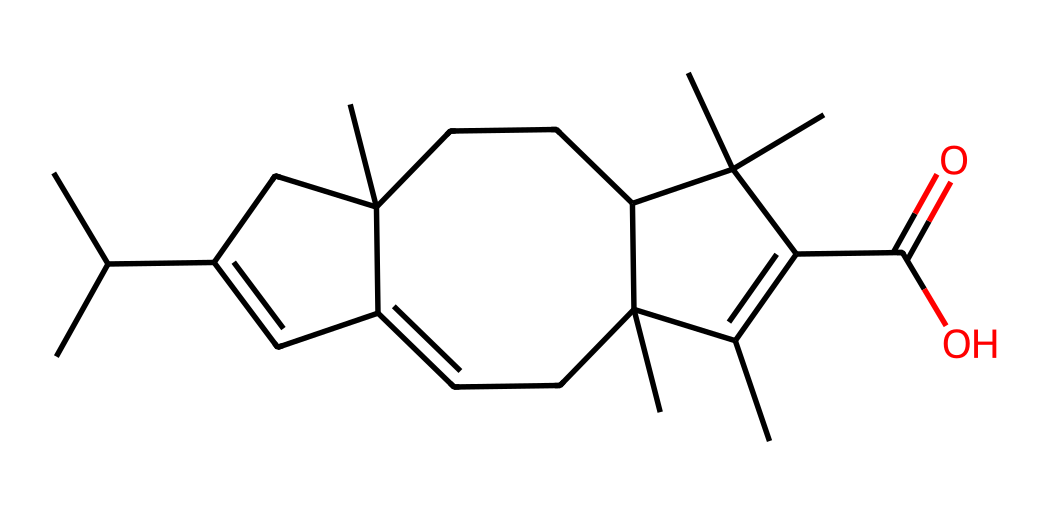What is the functional group present in this chemical structure? The SMILES representation shows a carbonyl group (C=O), which is characteristic of ketones. This functional group is typically located near the center of the molecule, visible in the structure.
Answer: carbonyl How many carbon atoms are in the structure? By analyzing the SMILES representation, we can count a total of 20 carbon atoms. Each capital "C" represents a carbon atom, and there are numerous branching structures indicated.
Answer: 20 What type of chemical is rosin classified as? Rosin is primarily classified as a mixture of terpenes and its derivatives; however, it also contains ketones as indicated by the structure and functional groups present.
Answer: mixture What is the degree of unsaturation in this molecule? The degree of unsaturation can be calculated by using the formula (1 + number of rings + number of double bonds - number of hydrogens/2). This structure has multiple rings and double bonds, leading to a degree of unsaturation of 8.
Answer: 8 What is the highest oxidation state of carbon displayed in this structure? In the structure, the carbon atom in the carbonyl group, as part of the ketone, is in a higher oxidation state due to being bonded to an oxygen atom through a double bond, indicating that it has reached a carbon oxidation state of +2.
Answer: +2 